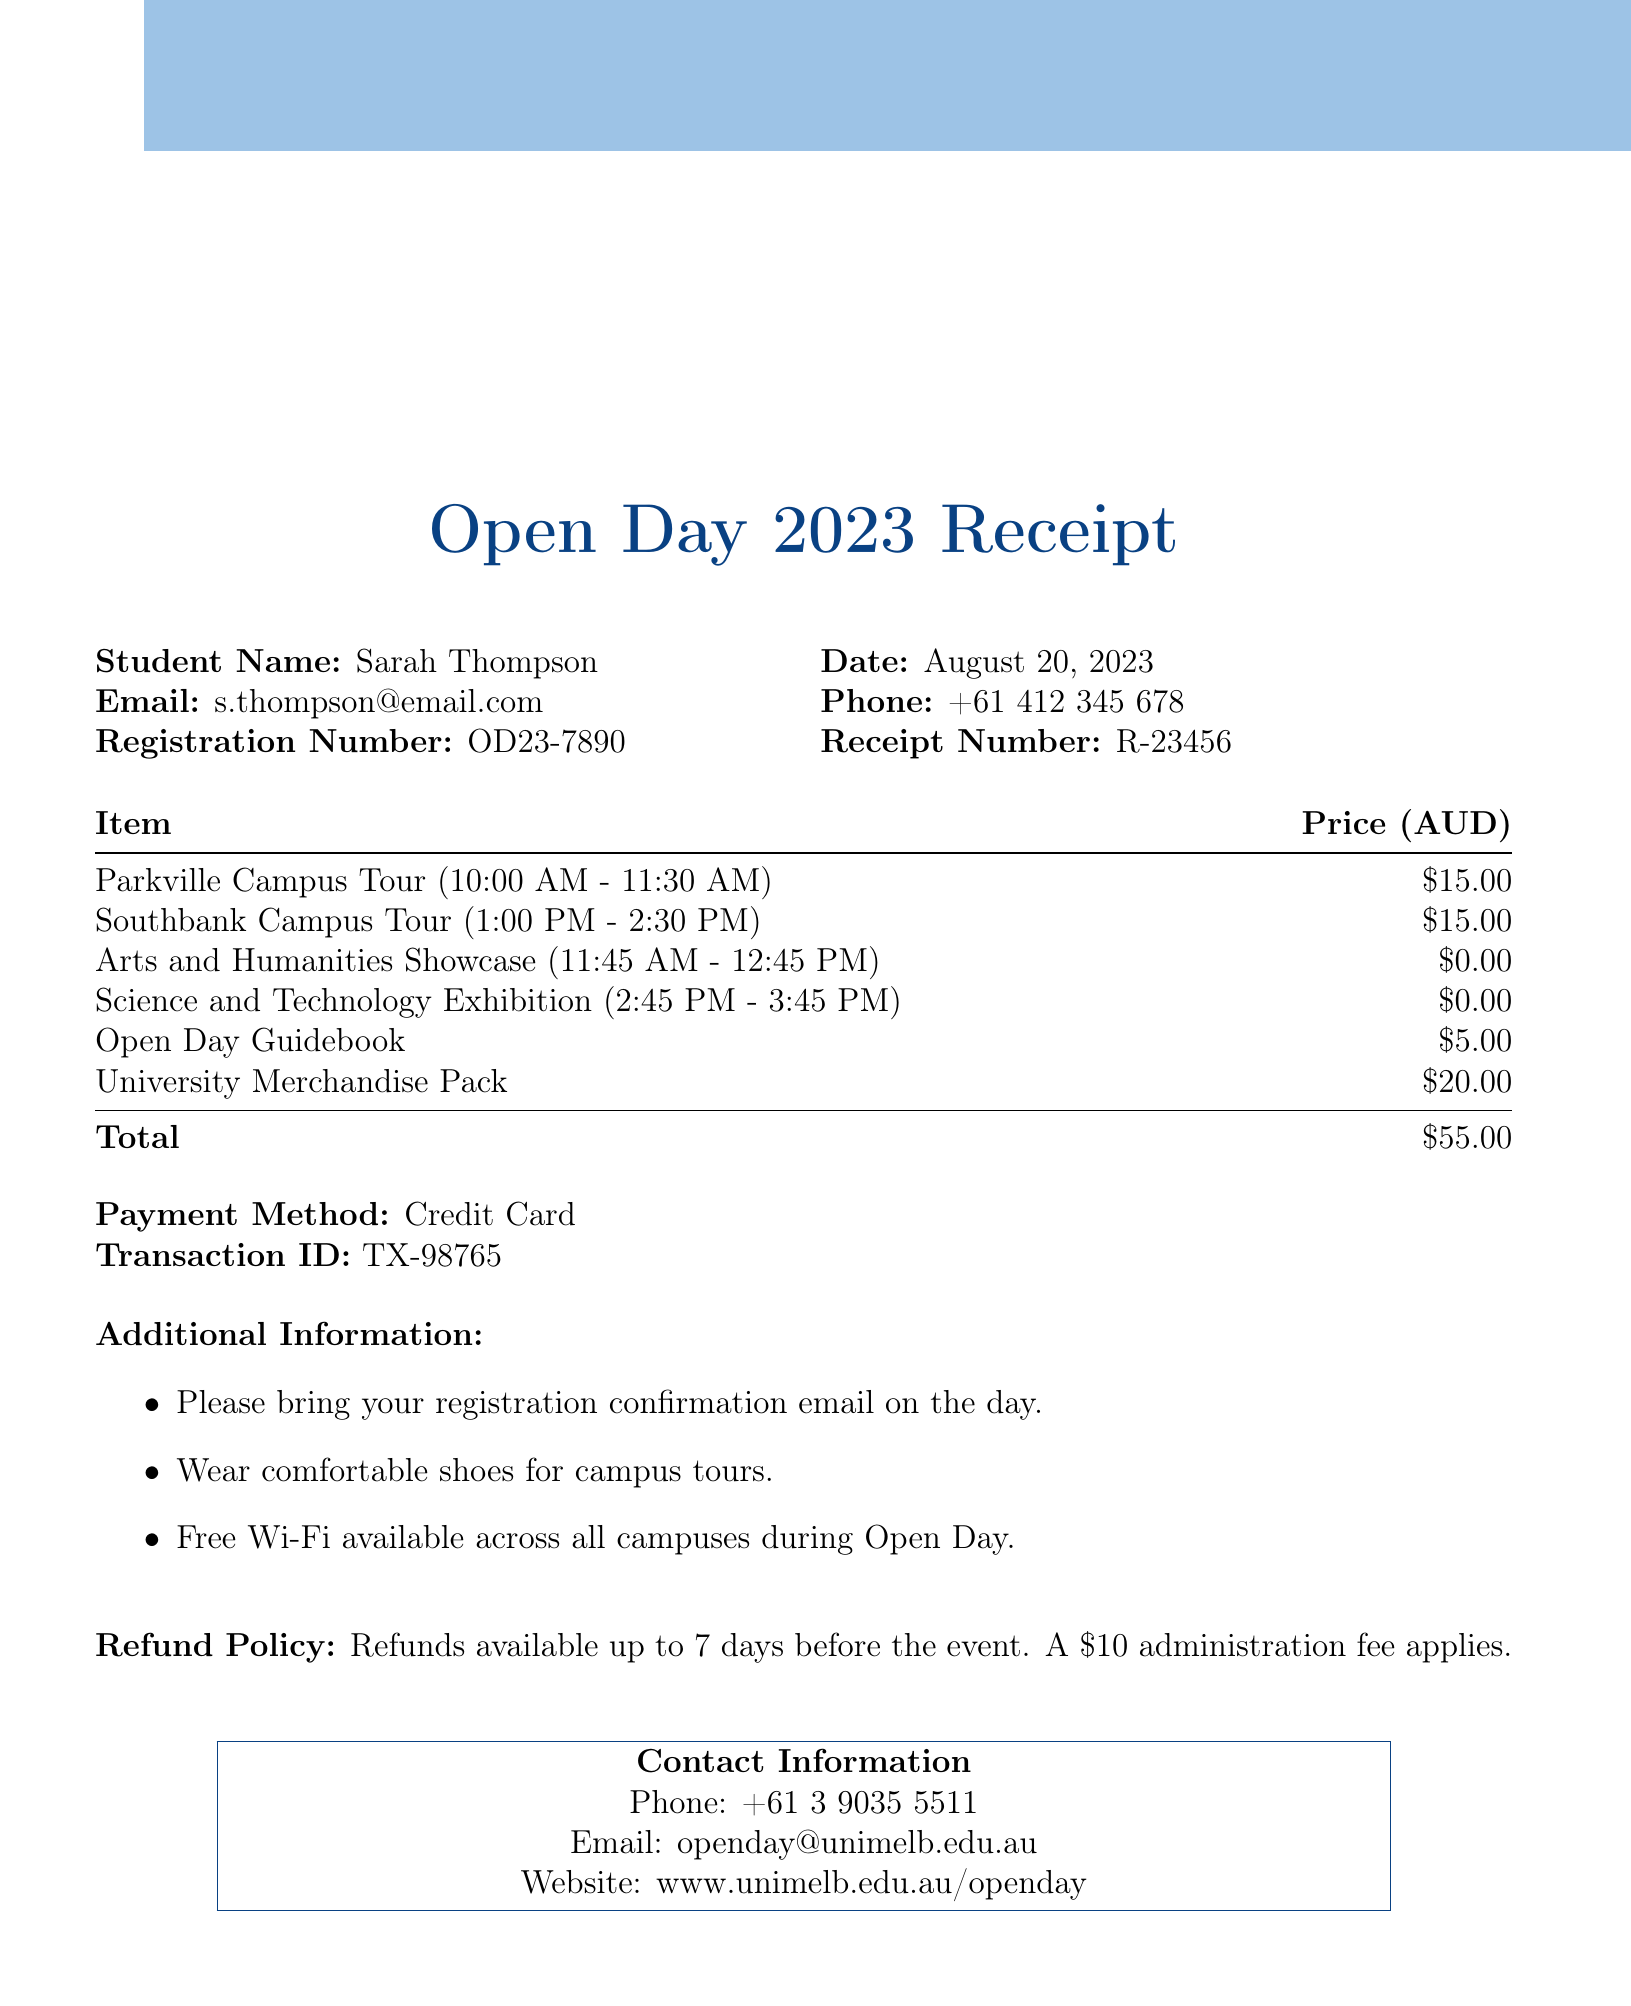what is the name of the university? The university name is stated at the top of the document.
Answer: University of Melbourne what is the date of the Open Day event? The date of the event is mentioned clearly in the document.
Answer: August 20, 2023 how much is the Parkville Campus Tour? The price for the campus tour is listed in the itemized section of the receipt.
Answer: $15.00 what is the total amount paid? The total amount is calculated as the sum of all the individual items listed.
Answer: $55.00 what time does the Science and Technology Exhibition start? The start time for the exhibition is included in the schedule of events.
Answer: 2:45 PM how many add-ons are available? The document lists the available add-ons.
Answer: 2 what is the refund policy for the event? The refund policy is stated in a specific section of the document.
Answer: Refunds available up to 7 days before the event. A $10 administration fee applies what should attendees bring on the day? The additional information section specifies what attendees should have when attending the event.
Answer: Registration confirmation email what is the contact email for the Open Day? The contact email is provided in the contact information section.
Answer: openday@unimelb.edu.au 